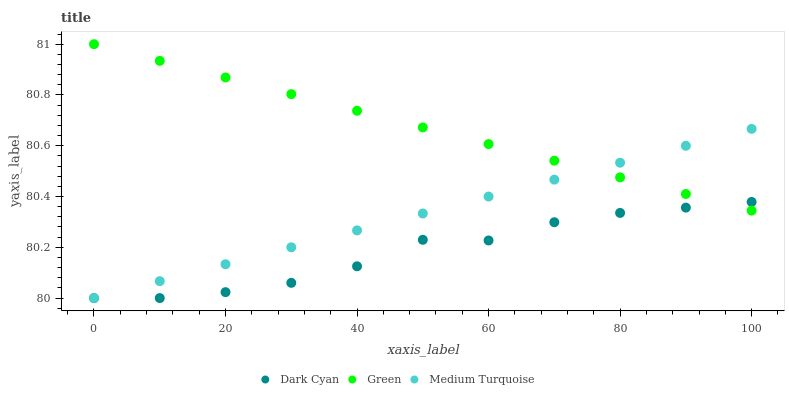Does Dark Cyan have the minimum area under the curve?
Answer yes or no. Yes. Does Green have the maximum area under the curve?
Answer yes or no. Yes. Does Medium Turquoise have the minimum area under the curve?
Answer yes or no. No. Does Medium Turquoise have the maximum area under the curve?
Answer yes or no. No. Is Medium Turquoise the smoothest?
Answer yes or no. Yes. Is Dark Cyan the roughest?
Answer yes or no. Yes. Is Green the smoothest?
Answer yes or no. No. Is Green the roughest?
Answer yes or no. No. Does Dark Cyan have the lowest value?
Answer yes or no. Yes. Does Green have the lowest value?
Answer yes or no. No. Does Green have the highest value?
Answer yes or no. Yes. Does Medium Turquoise have the highest value?
Answer yes or no. No. Does Medium Turquoise intersect Green?
Answer yes or no. Yes. Is Medium Turquoise less than Green?
Answer yes or no. No. Is Medium Turquoise greater than Green?
Answer yes or no. No. 